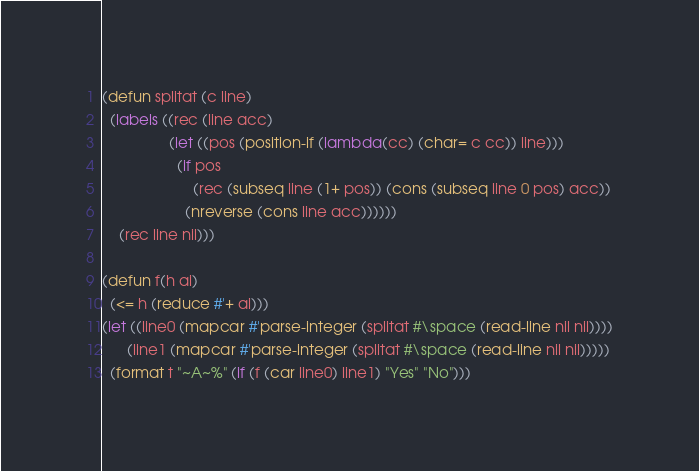<code> <loc_0><loc_0><loc_500><loc_500><_Lisp_>(defun splitat (c line)
  (labels ((rec (line acc)
				(let ((pos (position-if (lambda(cc) (char= c cc)) line)))
				  (if pos
					  (rec (subseq line (1+ pos)) (cons (subseq line 0 pos) acc))
					(nreverse (cons line acc))))))
	(rec line nil)))

(defun f(h ai)
  (<= h (reduce #'+ ai)))
(let ((line0 (mapcar #'parse-integer (splitat #\space (read-line nil nil))))
      (line1 (mapcar #'parse-integer (splitat #\space (read-line nil nil)))))
  (format t "~A~%" (if (f (car line0) line1) "Yes" "No")))
</code> 